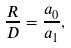Convert formula to latex. <formula><loc_0><loc_0><loc_500><loc_500>\frac { R } { D } = \frac { a _ { 0 } } { a _ { 1 } } ,</formula> 